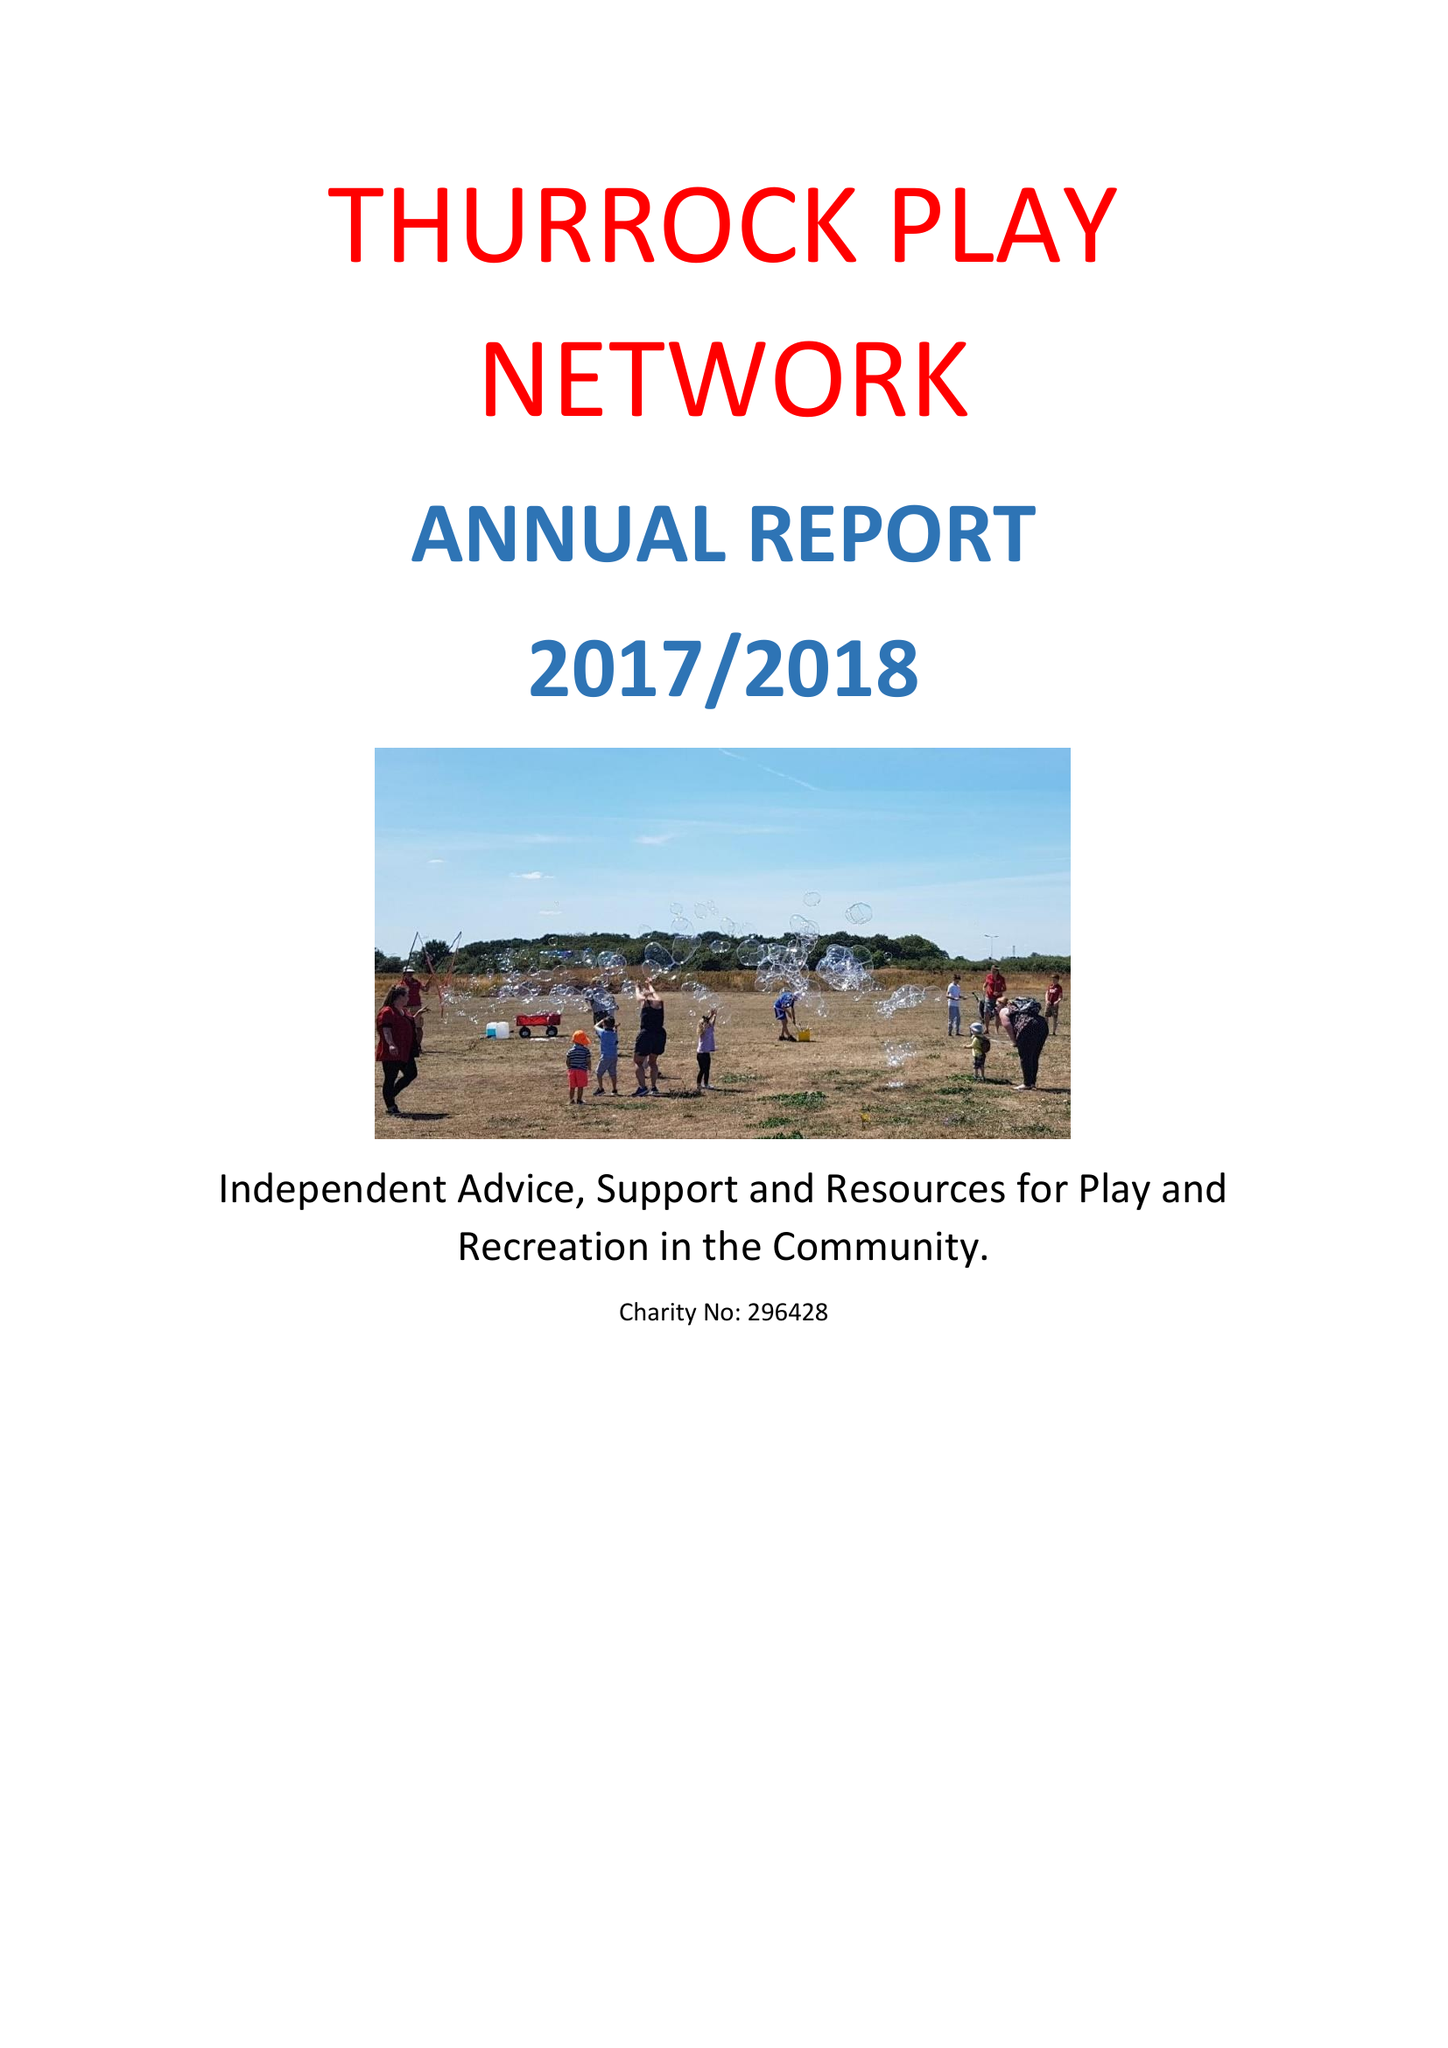What is the value for the address__street_line?
Answer the question using a single word or phrase. HEATH ROAD 